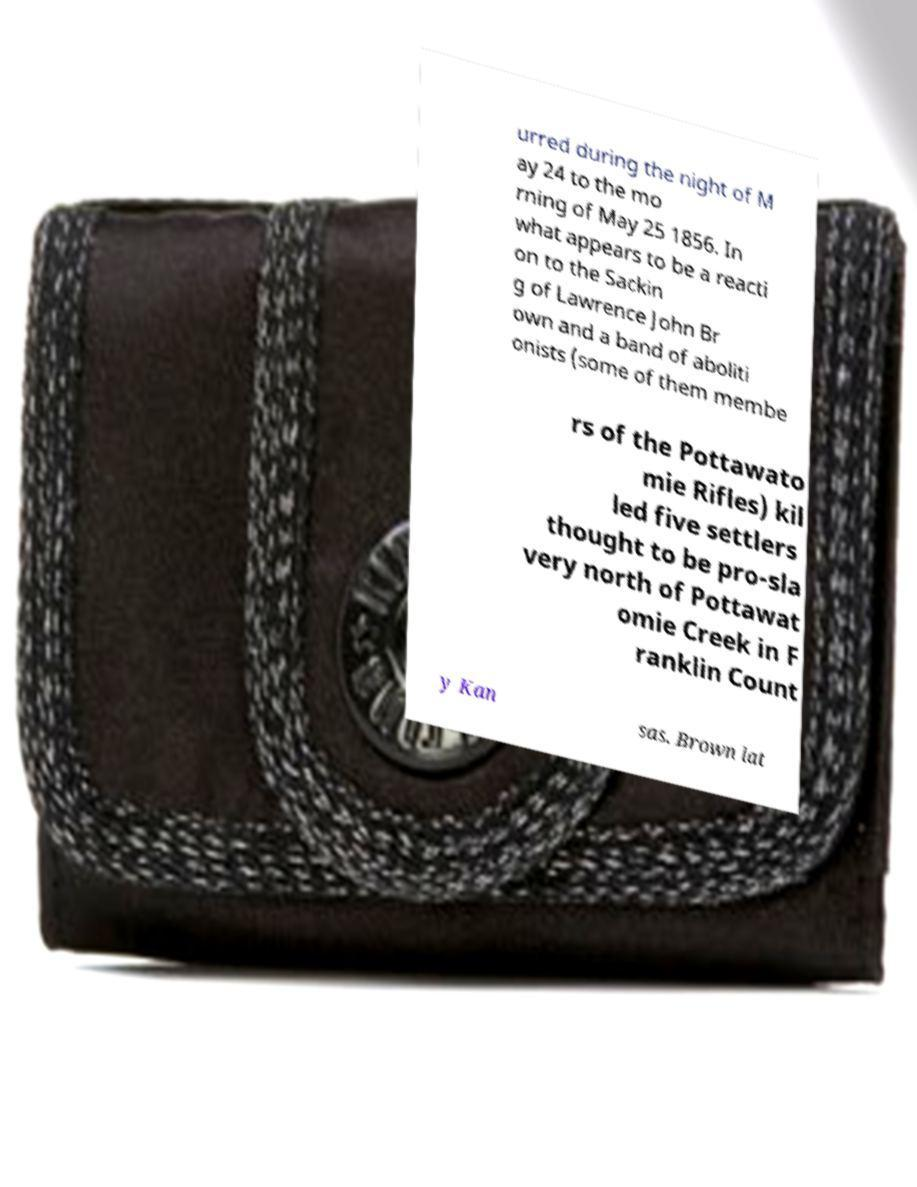For documentation purposes, I need the text within this image transcribed. Could you provide that? urred during the night of M ay 24 to the mo rning of May 25 1856. In what appears to be a reacti on to the Sackin g of Lawrence John Br own and a band of aboliti onists (some of them membe rs of the Pottawato mie Rifles) kil led five settlers thought to be pro-sla very north of Pottawat omie Creek in F ranklin Count y Kan sas. Brown lat 